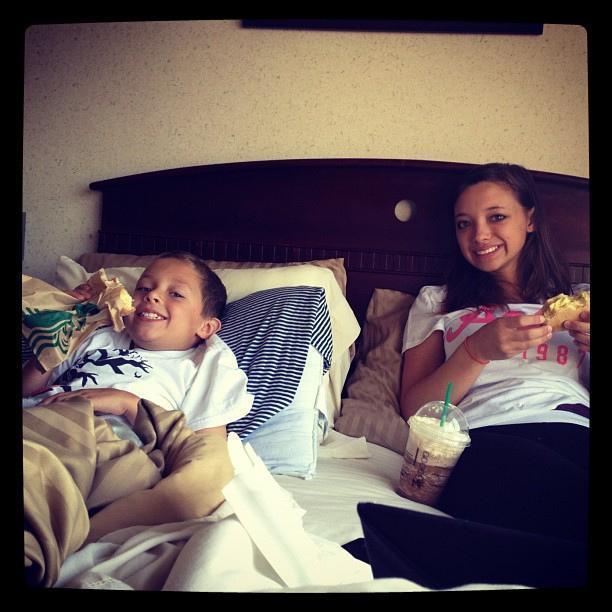What food place did the children get their food from?
Choose the correct response, then elucidate: 'Answer: answer
Rationale: rationale.'
Options: Wendys, starbucks, mcdonalds, dunkin donuts. Answer: starbucks.
Rationale: There is the whipped-coffee-in-plastic cup next to the girl. 